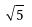<formula> <loc_0><loc_0><loc_500><loc_500>\sqrt { 5 }</formula> 